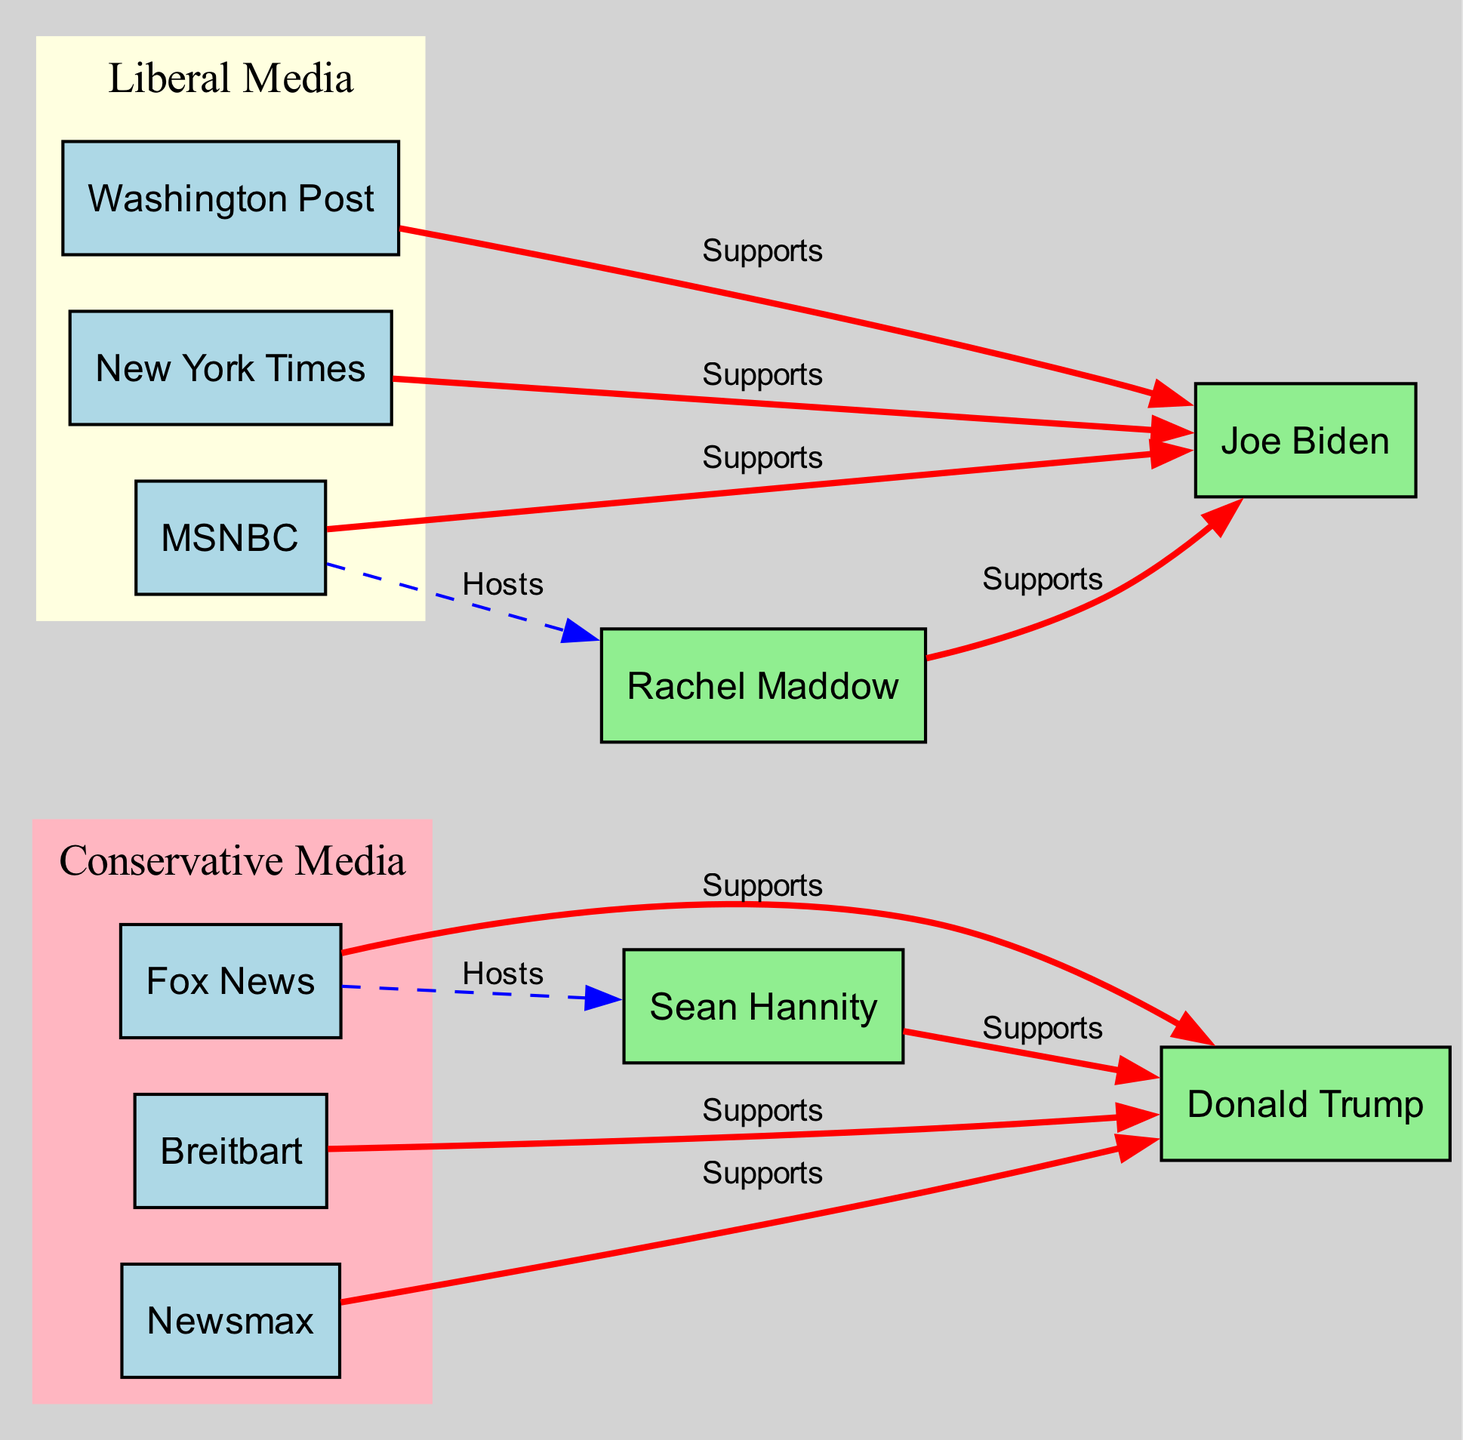What media outlet supports Donald Trump? The diagram indicates that three media outlets—Fox News, Breitbart, and Newsmax—are linked with the label "Supports" directed towards Donald Trump.
Answer: Fox News, Breitbart, Newsmax Which media outlet is associated with Rachel Maddow? The diagram shows that MSNBC hosts Rachel Maddow, illustrated by a direct edge labeled "Hosts" leading from MSNBC to Maddow.
Answer: MSNBC How many nodes are categorized as liberal media? The diagram comprises three liberal media outlets: Washington Post, New York Times, and MSNBC, which are clustered together in the designated liberal media section.
Answer: 3 Which figure is supported by Sean Hannity? An edge labeled "Supports" connects Sean Hannity to Donald Trump, indicating Hannity's support for Trump in the diagram.
Answer: Donald Trump Which media outlet has a connection to both Biden and Trump? The diagram reveals that Fox News is tied to Trump and that the connection ends at Sean Hannity, while MSNBC connects to Biden through Rachel Maddow. The only direct link from one media outlet to both figures is separate, thus clarifying the individual support.
Answer: None How many edges represent support for Joe Biden? Upon examining the diagram, there are three edges labeled "Supports" leading to Joe Biden from the Washington Post, New York Times, and MSNBC, making a total of three supporting edges.
Answer: 3 Which conservative outlet does Sean Hannity belong to? The diagram shows that Sean Hannity is hosted by Fox News, which categorizes him within the conservative media outlet area in the diagram.
Answer: Fox News What color represents conservative media in the diagram? The diagram visually distinguishes conservative media by using a light pink color for their subgraph, identifying the area associated with conservative media outlets.
Answer: Light pink How are the relationships between media outlets and political figures categorized in this diagram? The diagram categorizes the relationships into two distinct types: "Supports" displayed with red edges, typically showing support between media and political figures, and "Hosts" indicated with blue dashed edges, denoting the hosting relationships in the media.
Answer: Supports and Hosts 